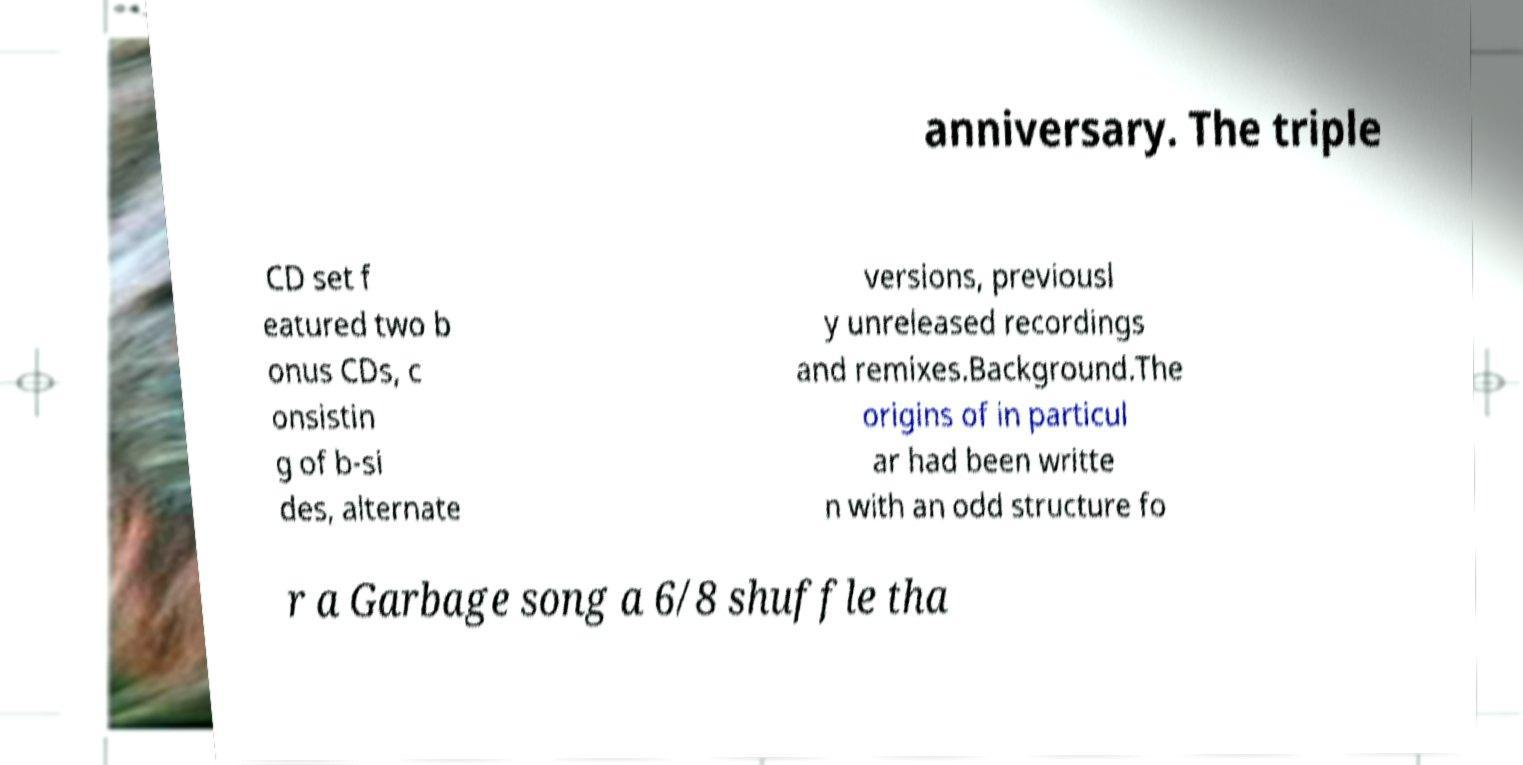Can you read and provide the text displayed in the image?This photo seems to have some interesting text. Can you extract and type it out for me? anniversary. The triple CD set f eatured two b onus CDs, c onsistin g of b-si des, alternate versions, previousl y unreleased recordings and remixes.Background.The origins of in particul ar had been writte n with an odd structure fo r a Garbage song a 6/8 shuffle tha 